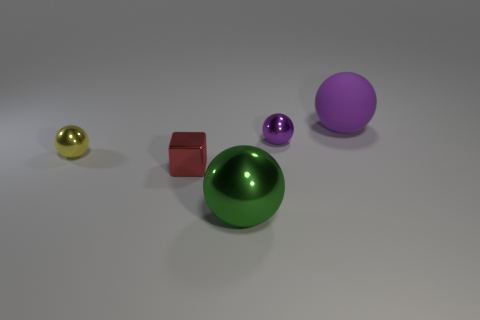There is a green thing that is made of the same material as the small red object; what size is it?
Make the answer very short. Large. Is there anything else that has the same color as the tiny metal block?
Your answer should be very brief. No. Is the material of the tiny red object the same as the large sphere behind the tiny red shiny block?
Offer a very short reply. No. What is the material of the tiny yellow thing that is the same shape as the large green object?
Offer a very short reply. Metal. Are there any other things that are the same material as the large purple thing?
Ensure brevity in your answer.  No. Does the tiny ball on the left side of the block have the same material as the object right of the tiny purple object?
Offer a very short reply. No. The object that is right of the purple thing left of the thing behind the tiny purple metal sphere is what color?
Provide a short and direct response. Purple. How many other objects are the same shape as the tiny red thing?
Provide a succinct answer. 0. How many things are either metallic balls or balls in front of the large purple sphere?
Make the answer very short. 3. Are there any metallic spheres that have the same size as the red object?
Provide a short and direct response. Yes. 